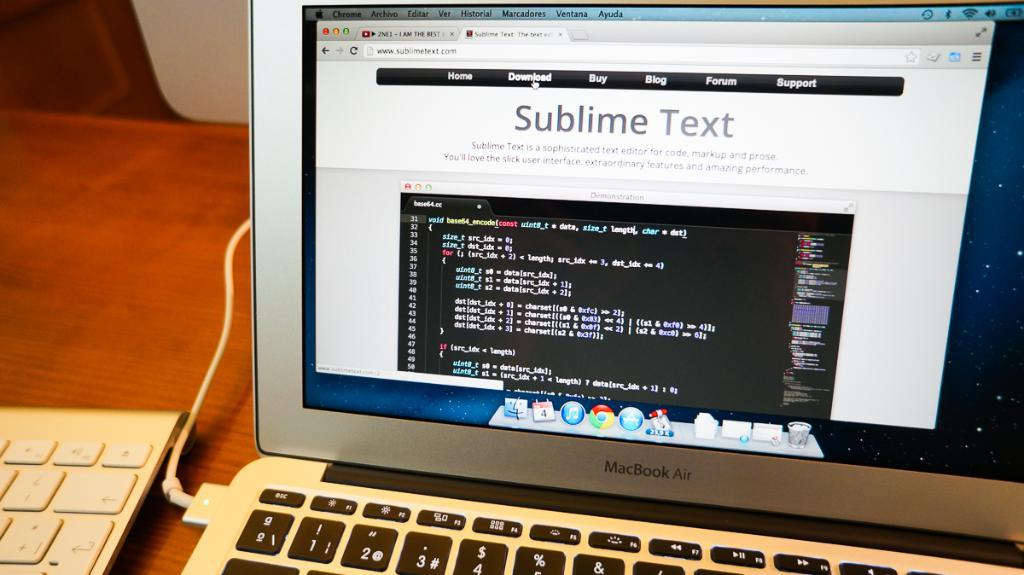<image>
Relay a brief, clear account of the picture shown. A computer screen is on a page that is labeled Sublime Text. 